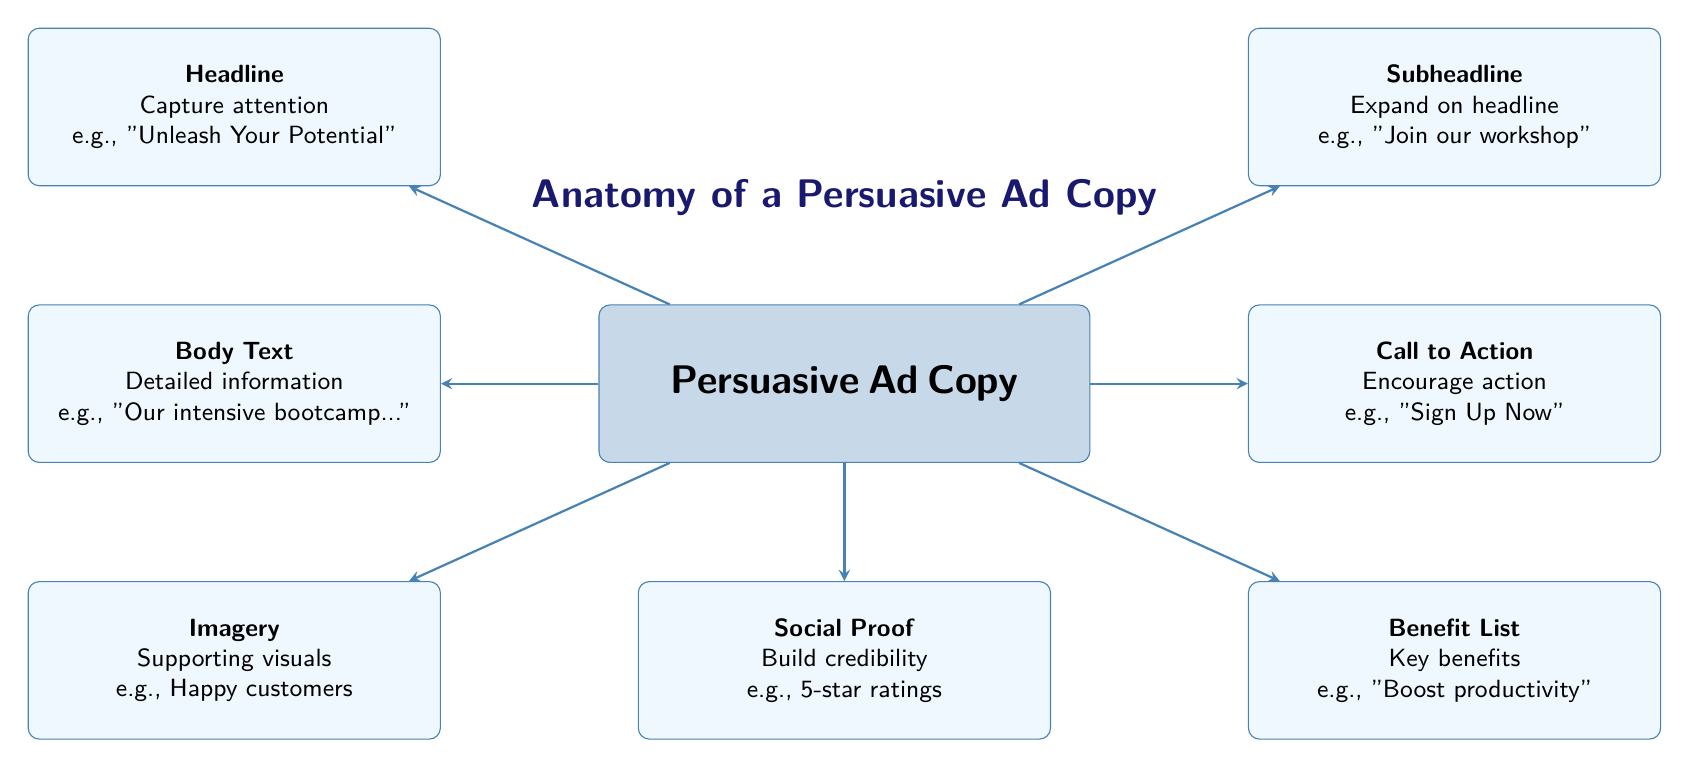What is the main topic of the diagram? The central node states "Persuasive Ad Copy," indicating that the overall focus of the diagram is on the elements that contribute to crafting effective advertising text.
Answer: Persuasive Ad Copy How many elements are surrounding the central node? There are six surrounding elements, each relating to different components of persuasive ad copy, plus the central node itself.
Answer: 6 What is the role of the 'Call to Action'? The 'Call to Action' encourages action, motivating the audience to take a step such as signing up or purchasing.
Answer: Encourage action Which element is placed above the central node? The 'Headline' is positioned above the central node, signifying it captures the audience's attention first.
Answer: Headline What supporting elements are found below the primary ad copy? The elements below the central node are 'Imagery' and 'Social Proof,' both serving to enhance the message.
Answer: Imagery and Social Proof Which node explains detailed information about the ad copy? The 'Body Text' node contains detailed information about the ad, elaborating on what the advertisement is promoting.
Answer: Body Text How does the 'Subheadline' relate to the 'Headline'? The 'Subheadline' expands on what is introduced in the 'Headline', providing additional context or details to entice the audience further.
Answer: Expand on headline What is an example given for 'Benefits List'? The 'Benefits List' offers key benefits of the product or service, with an example stated as "Boost productivity" in the diagram.
Answer: Boost productivity What is the significance of 'Social Proof' in advertising? 'Social Proof' is significant as it builds credibility, providing evidence that others have had positive experiences with the product or service.
Answer: Build credibility 